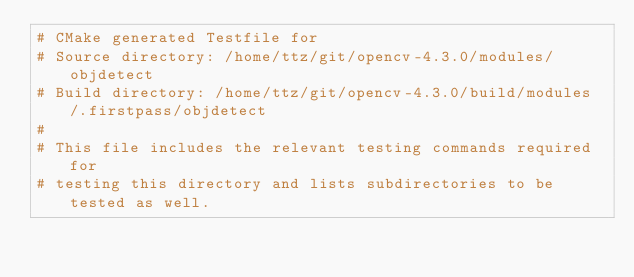<code> <loc_0><loc_0><loc_500><loc_500><_CMake_># CMake generated Testfile for 
# Source directory: /home/ttz/git/opencv-4.3.0/modules/objdetect
# Build directory: /home/ttz/git/opencv-4.3.0/build/modules/.firstpass/objdetect
# 
# This file includes the relevant testing commands required for 
# testing this directory and lists subdirectories to be tested as well.
</code> 